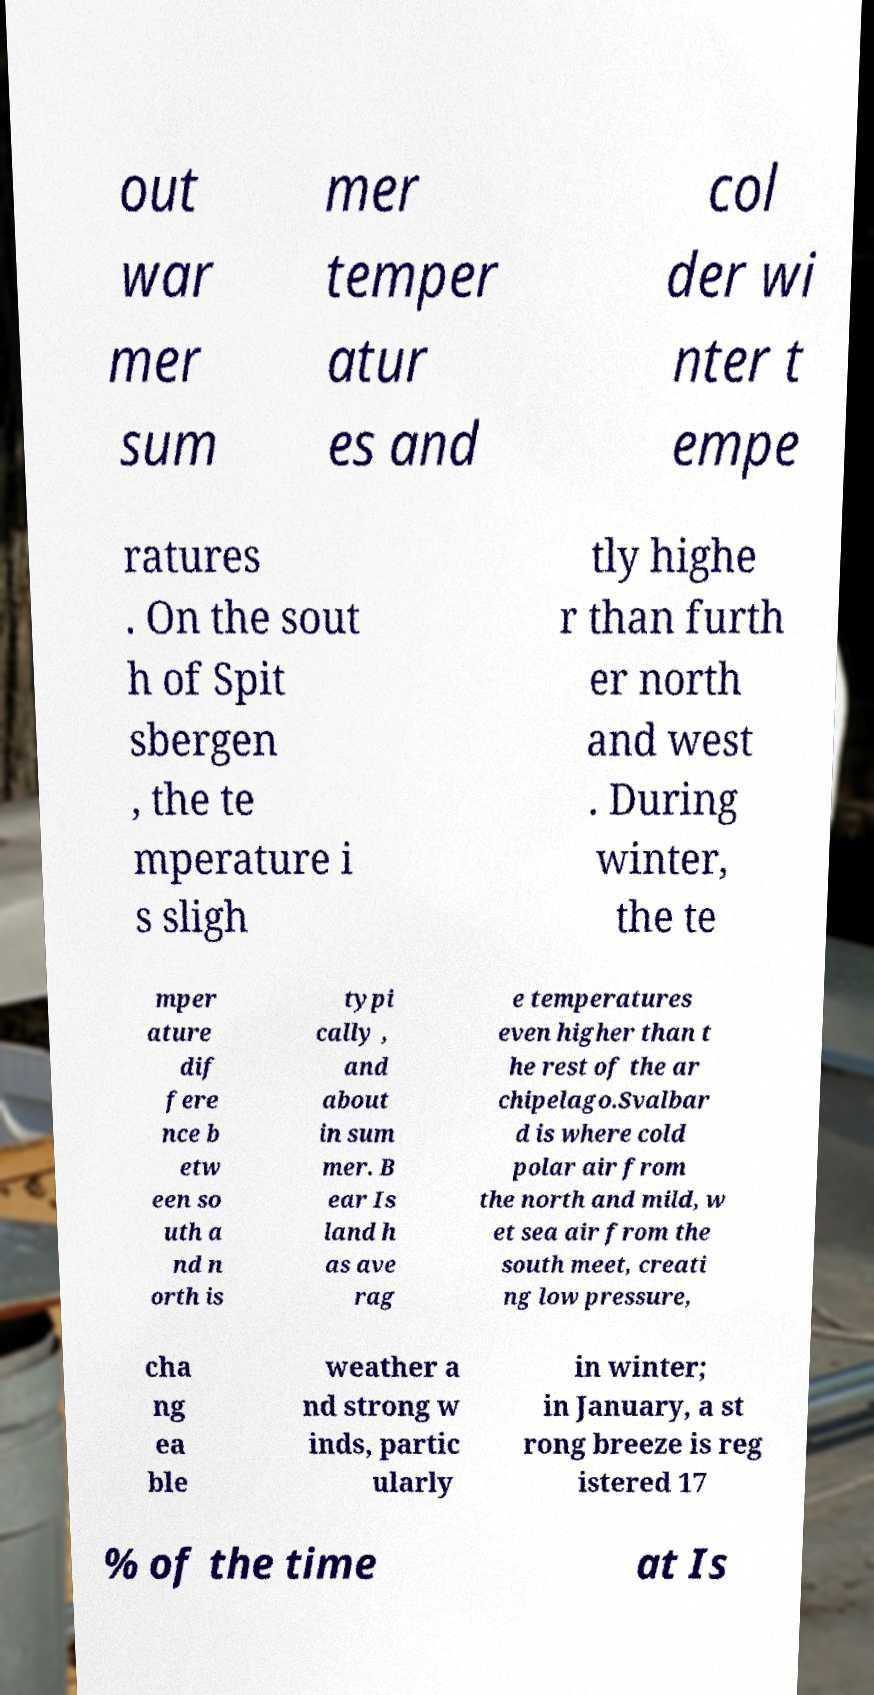Can you accurately transcribe the text from the provided image for me? out war mer sum mer temper atur es and col der wi nter t empe ratures . On the sout h of Spit sbergen , the te mperature i s sligh tly highe r than furth er north and west . During winter, the te mper ature dif fere nce b etw een so uth a nd n orth is typi cally , and about in sum mer. B ear Is land h as ave rag e temperatures even higher than t he rest of the ar chipelago.Svalbar d is where cold polar air from the north and mild, w et sea air from the south meet, creati ng low pressure, cha ng ea ble weather a nd strong w inds, partic ularly in winter; in January, a st rong breeze is reg istered 17 % of the time at Is 